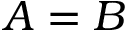<formula> <loc_0><loc_0><loc_500><loc_500>A = B</formula> 